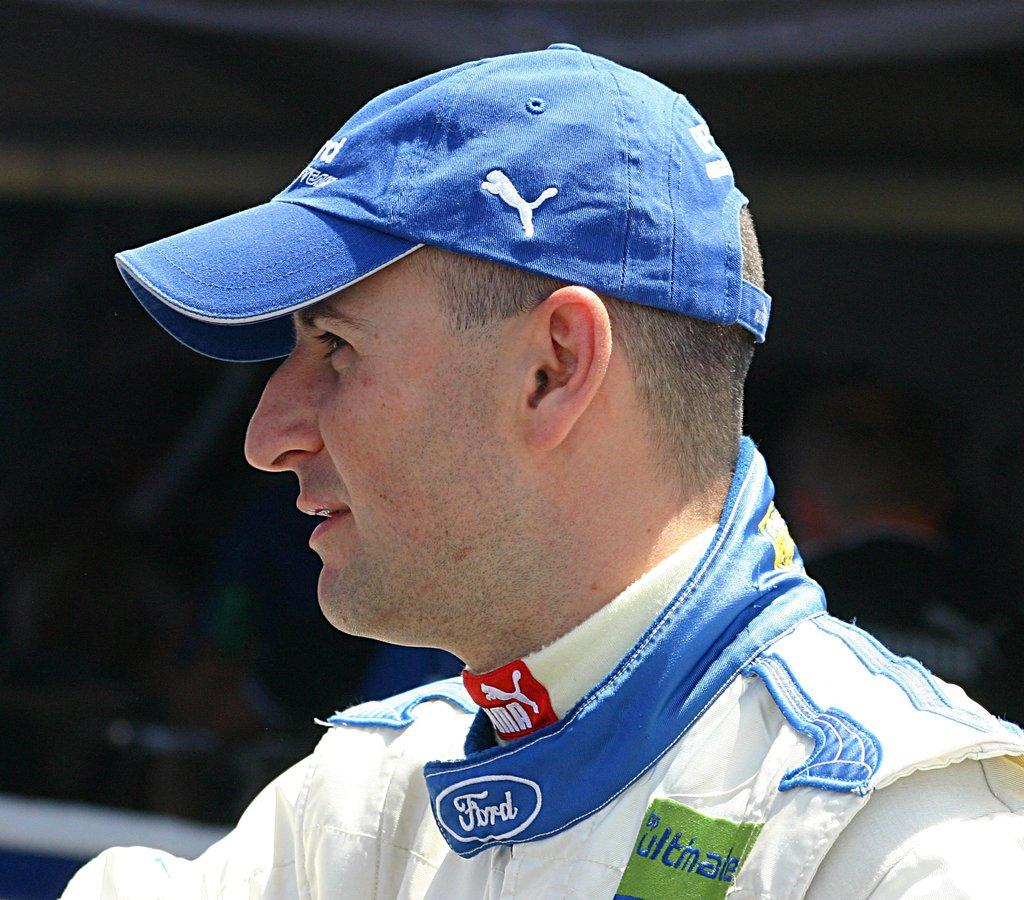<image>
Offer a succinct explanation of the picture presented. a man wearing a Puma ballcap and wearing a jacket by Ford 